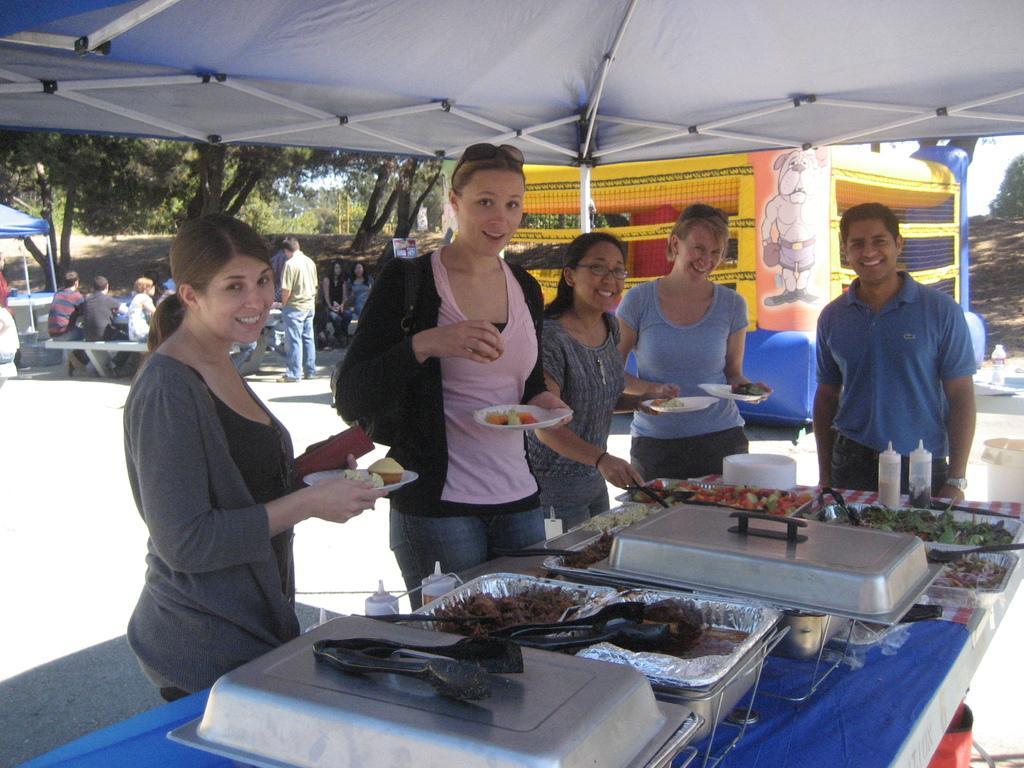Describe this image in one or two sentences. In this picture we can observe some people standing in front of a table on which there is some food places in the dishes. There are women and a man near the table under the tent. In the background we can observe trees and some people sitting on the bench. 